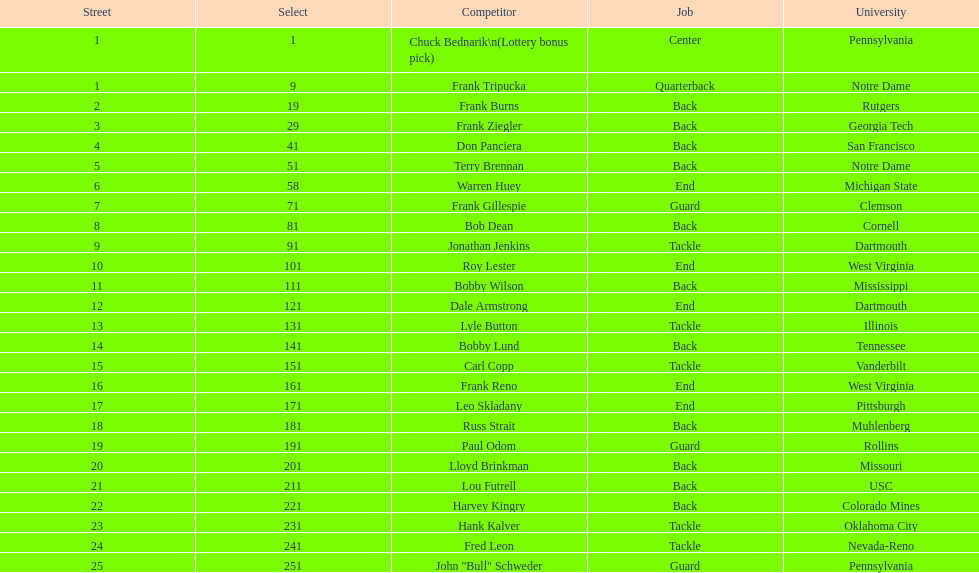How many players were from notre dame? 2. 